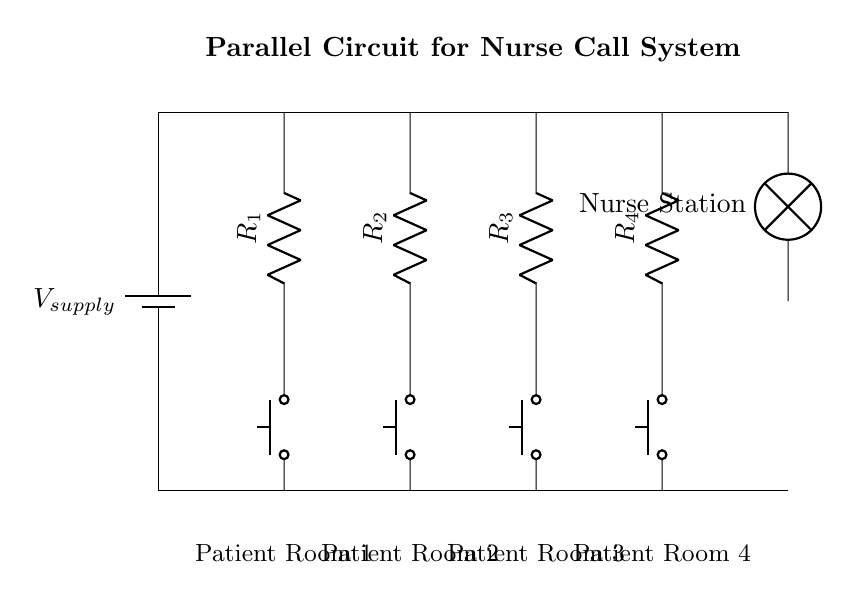What type of circuit is represented in this diagram? The diagram shows a parallel circuit, as indicated by multiple branches that connect to a common voltage source. In a parallel circuit, each component is connected directly across the voltage source, allowing for separate current paths.
Answer: Parallel How many nurse call buttons are included in the circuit? The diagram clearly shows four nurse call buttons. Each button is represented as a distinct component in the parallel configuration leading to the nurse station indicator.
Answer: Four What happens when one of the buttons is pressed? When one button is pressed, it completes its individual circuit branch, allowing current to flow to the nurse station indicator. In a parallel circuit, this action does not affect the other branches, so the remaining buttons and their circuits remain functional.
Answer: It alerts the nurse station What is the purpose of the resistors in this circuit? The resistors in the circuit are used to limit the current flowing through the system when a button is pressed. By doing so, they help protect the nurse call system from excessive current that could damage the components.
Answer: To limit current Which component indicates that a call has been made to the nurse station? The lamp labeled "Nurse Station" serves as the indicator that a call has been made. When any button in the parallel circuit is pressed, it illuminates the lamp, signaling the nurse.
Answer: Lamp How would the current distribution differ if one button is pressed compared to pressing all four? Pressing only one button directs current through that branch, with no impact on the other branches, which continue to have no current flow. If all four buttons are pressed simultaneously, current will distribute among all branches equally, as each branch is connected to the same voltage source.
Answer: Distribution changes with one versus four pressed What is the role of the battery in the circuit? The battery acts as the power supply for the circuit, providing the necessary voltage to drive current through the components when a button is pressed. Its voltage remains constant across all branches of the parallel circuit.
Answer: Power supply 